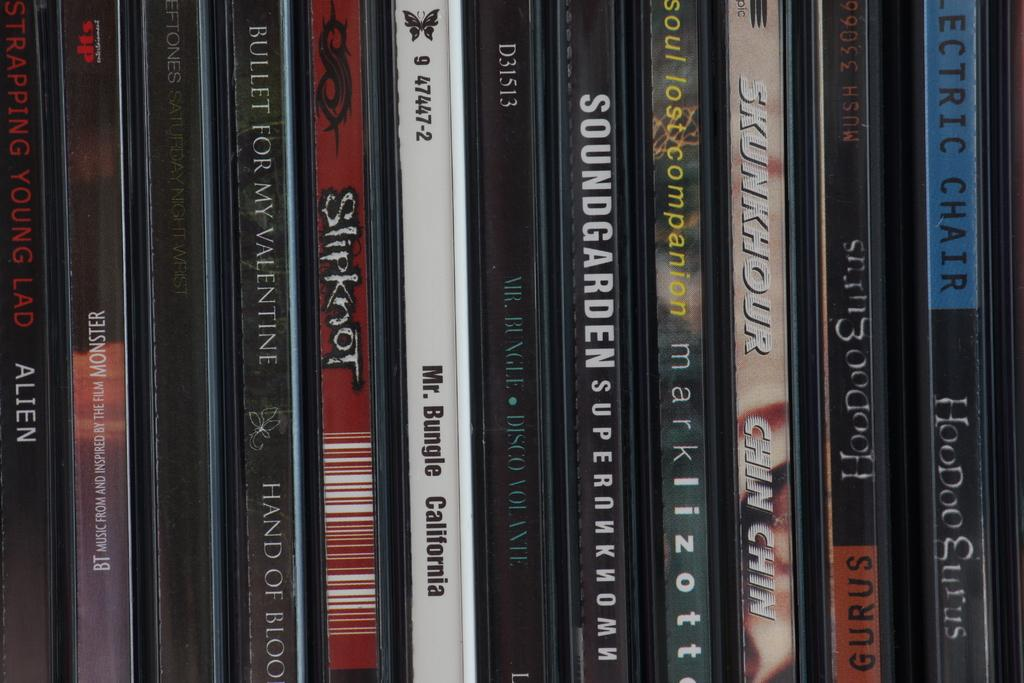<image>
Offer a succinct explanation of the picture presented. A row of compact discs include alternative bands like Mr Bungle, Bullet for My Valentine and Strapping Young Lad. 